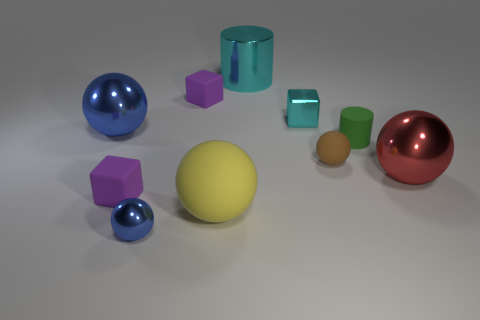How many objects are either metal objects that are in front of the tiny brown rubber thing or purple objects that are behind the red ball?
Provide a short and direct response. 3. Do the tiny brown matte object and the cyan shiny thing to the right of the large cyan object have the same shape?
Offer a very short reply. No. How many other things are there of the same shape as the big yellow object?
Keep it short and to the point. 4. What number of objects are either rubber balls or large cyan balls?
Make the answer very short. 2. Is the matte cylinder the same color as the tiny matte sphere?
Provide a succinct answer. No. The small purple rubber object behind the blue sphere behind the yellow sphere is what shape?
Give a very brief answer. Cube. Is the number of gray matte objects less than the number of red shiny objects?
Ensure brevity in your answer.  Yes. What size is the shiny ball that is to the left of the small green matte thing and behind the large rubber thing?
Provide a succinct answer. Large. Is the yellow rubber object the same size as the brown matte object?
Keep it short and to the point. No. Does the large object behind the large blue metal thing have the same color as the rubber cylinder?
Offer a very short reply. No. 